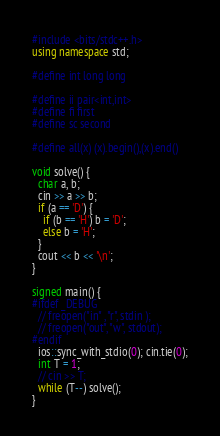Convert code to text. <code><loc_0><loc_0><loc_500><loc_500><_C++_>#include <bits/stdc++.h>
using namespace std;

#define int long long

#define ii pair<int,int>
#define fi first
#define sc second

#define all(x) (x).begin(),(x).end()

void solve() {
  char a, b;
  cin >> a >> b;
  if (a == 'D') {
    if (b == 'H') b = 'D';
    else b = 'H';
  }
  cout << b << '\n';
}

signed main() {
#ifdef _DEBUG
  // freopen("in" , "r", stdin );
  // freopen("out", "w", stdout);
#endif
  ios::sync_with_stdio(0); cin.tie(0);
  int T = 1;
  // cin >> T;
  while (T--) solve();
}
</code> 